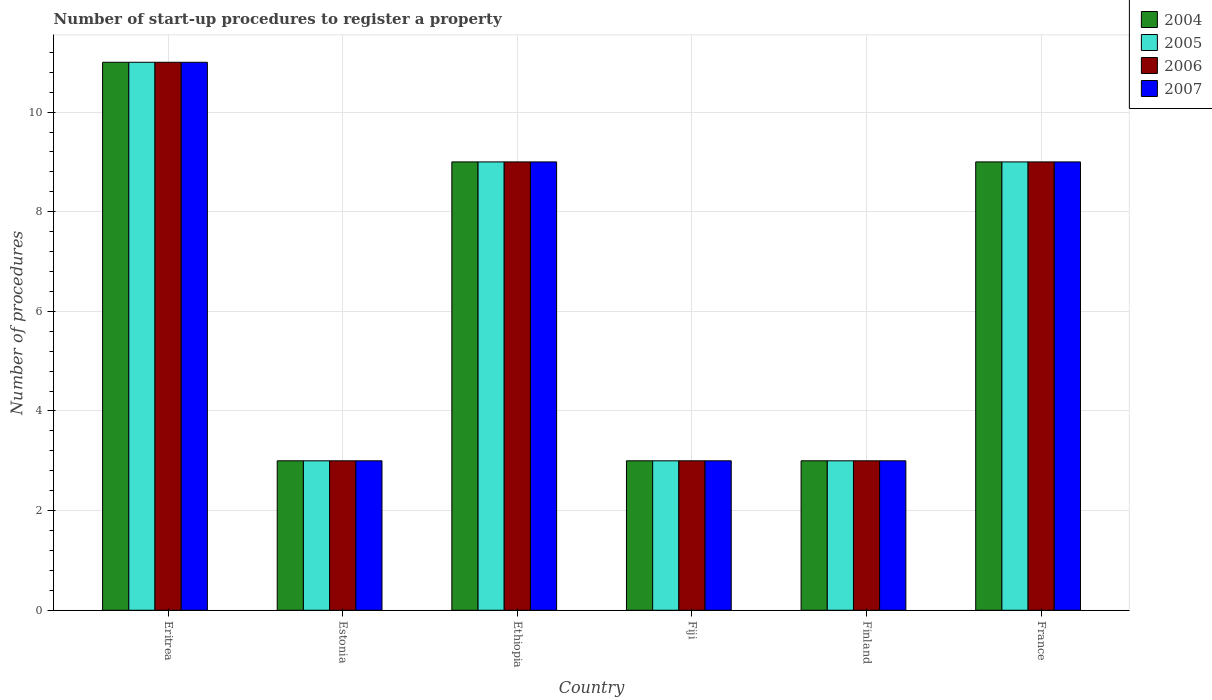How many different coloured bars are there?
Ensure brevity in your answer.  4. Are the number of bars per tick equal to the number of legend labels?
Offer a terse response. Yes. How many bars are there on the 4th tick from the right?
Offer a very short reply. 4. What is the label of the 5th group of bars from the left?
Provide a succinct answer. Finland. What is the number of procedures required to register a property in 2005 in Fiji?
Provide a succinct answer. 3. In which country was the number of procedures required to register a property in 2006 maximum?
Your response must be concise. Eritrea. In which country was the number of procedures required to register a property in 2004 minimum?
Provide a succinct answer. Estonia. What is the total number of procedures required to register a property in 2004 in the graph?
Make the answer very short. 38. What is the difference between the number of procedures required to register a property in 2006 in Eritrea and that in Estonia?
Keep it short and to the point. 8. What is the average number of procedures required to register a property in 2004 per country?
Provide a short and direct response. 6.33. What is the difference between the number of procedures required to register a property of/in 2005 and number of procedures required to register a property of/in 2006 in Estonia?
Your answer should be compact. 0. In how many countries, is the number of procedures required to register a property in 2006 greater than 4.8?
Offer a terse response. 3. What is the ratio of the number of procedures required to register a property in 2006 in Estonia to that in France?
Offer a very short reply. 0.33. Is the difference between the number of procedures required to register a property in 2005 in Eritrea and Ethiopia greater than the difference between the number of procedures required to register a property in 2006 in Eritrea and Ethiopia?
Your response must be concise. No. What is the difference between the highest and the lowest number of procedures required to register a property in 2006?
Give a very brief answer. 8. Is it the case that in every country, the sum of the number of procedures required to register a property in 2005 and number of procedures required to register a property in 2004 is greater than the number of procedures required to register a property in 2007?
Give a very brief answer. Yes. How many bars are there?
Your answer should be compact. 24. How many countries are there in the graph?
Your response must be concise. 6. What is the difference between two consecutive major ticks on the Y-axis?
Your answer should be very brief. 2. What is the title of the graph?
Keep it short and to the point. Number of start-up procedures to register a property. Does "2011" appear as one of the legend labels in the graph?
Give a very brief answer. No. What is the label or title of the X-axis?
Keep it short and to the point. Country. What is the label or title of the Y-axis?
Give a very brief answer. Number of procedures. What is the Number of procedures of 2004 in Eritrea?
Offer a very short reply. 11. What is the Number of procedures of 2005 in Eritrea?
Your answer should be compact. 11. What is the Number of procedures of 2005 in Estonia?
Offer a terse response. 3. What is the Number of procedures of 2006 in Estonia?
Ensure brevity in your answer.  3. What is the Number of procedures of 2004 in Ethiopia?
Make the answer very short. 9. What is the Number of procedures of 2005 in Ethiopia?
Provide a short and direct response. 9. What is the Number of procedures in 2007 in Ethiopia?
Give a very brief answer. 9. What is the Number of procedures in 2004 in Fiji?
Offer a terse response. 3. What is the Number of procedures in 2005 in Fiji?
Your answer should be very brief. 3. What is the Number of procedures in 2006 in Fiji?
Give a very brief answer. 3. What is the Number of procedures in 2007 in Fiji?
Your response must be concise. 3. What is the Number of procedures of 2004 in Finland?
Keep it short and to the point. 3. What is the Number of procedures of 2006 in Finland?
Ensure brevity in your answer.  3. What is the Number of procedures in 2007 in Finland?
Offer a terse response. 3. What is the Number of procedures of 2004 in France?
Make the answer very short. 9. Across all countries, what is the maximum Number of procedures of 2004?
Your answer should be very brief. 11. Across all countries, what is the maximum Number of procedures in 2005?
Offer a terse response. 11. Across all countries, what is the minimum Number of procedures of 2004?
Ensure brevity in your answer.  3. Across all countries, what is the minimum Number of procedures of 2006?
Provide a succinct answer. 3. Across all countries, what is the minimum Number of procedures of 2007?
Your answer should be compact. 3. What is the total Number of procedures in 2004 in the graph?
Offer a very short reply. 38. What is the total Number of procedures of 2005 in the graph?
Give a very brief answer. 38. What is the difference between the Number of procedures of 2004 in Eritrea and that in Estonia?
Make the answer very short. 8. What is the difference between the Number of procedures in 2005 in Eritrea and that in Estonia?
Give a very brief answer. 8. What is the difference between the Number of procedures in 2007 in Eritrea and that in Estonia?
Keep it short and to the point. 8. What is the difference between the Number of procedures of 2004 in Eritrea and that in Ethiopia?
Ensure brevity in your answer.  2. What is the difference between the Number of procedures of 2007 in Eritrea and that in Ethiopia?
Provide a succinct answer. 2. What is the difference between the Number of procedures of 2005 in Eritrea and that in Fiji?
Provide a succinct answer. 8. What is the difference between the Number of procedures in 2006 in Eritrea and that in Fiji?
Your response must be concise. 8. What is the difference between the Number of procedures of 2004 in Eritrea and that in Finland?
Make the answer very short. 8. What is the difference between the Number of procedures of 2004 in Eritrea and that in France?
Keep it short and to the point. 2. What is the difference between the Number of procedures of 2005 in Eritrea and that in France?
Give a very brief answer. 2. What is the difference between the Number of procedures in 2006 in Eritrea and that in France?
Keep it short and to the point. 2. What is the difference between the Number of procedures of 2007 in Eritrea and that in France?
Your answer should be very brief. 2. What is the difference between the Number of procedures of 2004 in Estonia and that in Ethiopia?
Give a very brief answer. -6. What is the difference between the Number of procedures of 2006 in Estonia and that in Ethiopia?
Give a very brief answer. -6. What is the difference between the Number of procedures of 2005 in Estonia and that in Fiji?
Provide a short and direct response. 0. What is the difference between the Number of procedures of 2007 in Estonia and that in Fiji?
Your answer should be compact. 0. What is the difference between the Number of procedures of 2005 in Estonia and that in Finland?
Provide a short and direct response. 0. What is the difference between the Number of procedures in 2006 in Estonia and that in Finland?
Keep it short and to the point. 0. What is the difference between the Number of procedures of 2007 in Estonia and that in Finland?
Ensure brevity in your answer.  0. What is the difference between the Number of procedures of 2005 in Estonia and that in France?
Offer a terse response. -6. What is the difference between the Number of procedures in 2006 in Estonia and that in France?
Offer a terse response. -6. What is the difference between the Number of procedures of 2007 in Estonia and that in France?
Offer a terse response. -6. What is the difference between the Number of procedures in 2004 in Ethiopia and that in Fiji?
Your answer should be compact. 6. What is the difference between the Number of procedures in 2006 in Ethiopia and that in Fiji?
Your response must be concise. 6. What is the difference between the Number of procedures of 2006 in Ethiopia and that in Finland?
Offer a very short reply. 6. What is the difference between the Number of procedures of 2006 in Ethiopia and that in France?
Ensure brevity in your answer.  0. What is the difference between the Number of procedures of 2007 in Ethiopia and that in France?
Your answer should be compact. 0. What is the difference between the Number of procedures in 2006 in Fiji and that in Finland?
Provide a short and direct response. 0. What is the difference between the Number of procedures of 2004 in Finland and that in France?
Make the answer very short. -6. What is the difference between the Number of procedures of 2004 in Eritrea and the Number of procedures of 2005 in Estonia?
Your answer should be compact. 8. What is the difference between the Number of procedures in 2004 in Eritrea and the Number of procedures in 2006 in Estonia?
Your answer should be very brief. 8. What is the difference between the Number of procedures in 2004 in Eritrea and the Number of procedures in 2007 in Estonia?
Your answer should be compact. 8. What is the difference between the Number of procedures of 2005 in Eritrea and the Number of procedures of 2006 in Estonia?
Offer a terse response. 8. What is the difference between the Number of procedures in 2005 in Eritrea and the Number of procedures in 2007 in Estonia?
Your answer should be very brief. 8. What is the difference between the Number of procedures in 2006 in Eritrea and the Number of procedures in 2007 in Estonia?
Your answer should be very brief. 8. What is the difference between the Number of procedures in 2004 in Eritrea and the Number of procedures in 2006 in Ethiopia?
Your answer should be very brief. 2. What is the difference between the Number of procedures of 2005 in Eritrea and the Number of procedures of 2006 in Ethiopia?
Your response must be concise. 2. What is the difference between the Number of procedures in 2005 in Eritrea and the Number of procedures in 2007 in Ethiopia?
Keep it short and to the point. 2. What is the difference between the Number of procedures in 2006 in Eritrea and the Number of procedures in 2007 in Ethiopia?
Your answer should be compact. 2. What is the difference between the Number of procedures of 2004 in Eritrea and the Number of procedures of 2006 in Fiji?
Your response must be concise. 8. What is the difference between the Number of procedures in 2005 in Eritrea and the Number of procedures in 2007 in Fiji?
Give a very brief answer. 8. What is the difference between the Number of procedures in 2004 in Eritrea and the Number of procedures in 2007 in Finland?
Your response must be concise. 8. What is the difference between the Number of procedures of 2005 in Eritrea and the Number of procedures of 2006 in Finland?
Offer a terse response. 8. What is the difference between the Number of procedures of 2006 in Eritrea and the Number of procedures of 2007 in Finland?
Offer a terse response. 8. What is the difference between the Number of procedures in 2004 in Eritrea and the Number of procedures in 2007 in France?
Your answer should be very brief. 2. What is the difference between the Number of procedures of 2004 in Estonia and the Number of procedures of 2005 in Ethiopia?
Provide a succinct answer. -6. What is the difference between the Number of procedures of 2006 in Estonia and the Number of procedures of 2007 in Ethiopia?
Keep it short and to the point. -6. What is the difference between the Number of procedures in 2004 in Estonia and the Number of procedures in 2005 in Fiji?
Your response must be concise. 0. What is the difference between the Number of procedures in 2004 in Estonia and the Number of procedures in 2006 in Fiji?
Keep it short and to the point. 0. What is the difference between the Number of procedures of 2004 in Estonia and the Number of procedures of 2006 in Finland?
Make the answer very short. 0. What is the difference between the Number of procedures in 2004 in Estonia and the Number of procedures in 2007 in Finland?
Keep it short and to the point. 0. What is the difference between the Number of procedures of 2004 in Estonia and the Number of procedures of 2005 in France?
Offer a terse response. -6. What is the difference between the Number of procedures in 2004 in Ethiopia and the Number of procedures in 2006 in Fiji?
Ensure brevity in your answer.  6. What is the difference between the Number of procedures in 2006 in Ethiopia and the Number of procedures in 2007 in Fiji?
Your answer should be very brief. 6. What is the difference between the Number of procedures of 2004 in Ethiopia and the Number of procedures of 2007 in Finland?
Your response must be concise. 6. What is the difference between the Number of procedures in 2005 in Ethiopia and the Number of procedures in 2006 in Finland?
Keep it short and to the point. 6. What is the difference between the Number of procedures in 2005 in Ethiopia and the Number of procedures in 2007 in Finland?
Keep it short and to the point. 6. What is the difference between the Number of procedures of 2004 in Ethiopia and the Number of procedures of 2005 in France?
Ensure brevity in your answer.  0. What is the difference between the Number of procedures in 2005 in Ethiopia and the Number of procedures in 2006 in France?
Your answer should be compact. 0. What is the difference between the Number of procedures in 2006 in Ethiopia and the Number of procedures in 2007 in France?
Provide a short and direct response. 0. What is the difference between the Number of procedures of 2004 in Fiji and the Number of procedures of 2006 in Finland?
Provide a succinct answer. 0. What is the difference between the Number of procedures in 2004 in Fiji and the Number of procedures in 2007 in Finland?
Ensure brevity in your answer.  0. What is the difference between the Number of procedures of 2005 in Fiji and the Number of procedures of 2006 in Finland?
Your response must be concise. 0. What is the difference between the Number of procedures in 2004 in Fiji and the Number of procedures in 2007 in France?
Your answer should be very brief. -6. What is the difference between the Number of procedures in 2005 in Fiji and the Number of procedures in 2006 in France?
Your answer should be compact. -6. What is the difference between the Number of procedures in 2005 in Fiji and the Number of procedures in 2007 in France?
Your answer should be compact. -6. What is the difference between the Number of procedures of 2004 in Finland and the Number of procedures of 2005 in France?
Your answer should be very brief. -6. What is the difference between the Number of procedures in 2004 in Finland and the Number of procedures in 2006 in France?
Your answer should be compact. -6. What is the difference between the Number of procedures of 2005 in Finland and the Number of procedures of 2007 in France?
Offer a terse response. -6. What is the difference between the Number of procedures in 2006 in Finland and the Number of procedures in 2007 in France?
Your answer should be compact. -6. What is the average Number of procedures in 2004 per country?
Make the answer very short. 6.33. What is the average Number of procedures in 2005 per country?
Offer a very short reply. 6.33. What is the average Number of procedures of 2006 per country?
Your answer should be very brief. 6.33. What is the average Number of procedures of 2007 per country?
Offer a very short reply. 6.33. What is the difference between the Number of procedures of 2004 and Number of procedures of 2006 in Eritrea?
Provide a short and direct response. 0. What is the difference between the Number of procedures of 2004 and Number of procedures of 2007 in Eritrea?
Ensure brevity in your answer.  0. What is the difference between the Number of procedures of 2005 and Number of procedures of 2007 in Eritrea?
Keep it short and to the point. 0. What is the difference between the Number of procedures in 2006 and Number of procedures in 2007 in Eritrea?
Provide a succinct answer. 0. What is the difference between the Number of procedures in 2004 and Number of procedures in 2006 in Estonia?
Provide a short and direct response. 0. What is the difference between the Number of procedures of 2005 and Number of procedures of 2006 in Estonia?
Give a very brief answer. 0. What is the difference between the Number of procedures in 2004 and Number of procedures in 2006 in Ethiopia?
Your answer should be compact. 0. What is the difference between the Number of procedures in 2004 and Number of procedures in 2007 in Ethiopia?
Your response must be concise. 0. What is the difference between the Number of procedures in 2004 and Number of procedures in 2007 in Fiji?
Ensure brevity in your answer.  0. What is the difference between the Number of procedures in 2004 and Number of procedures in 2006 in Finland?
Your response must be concise. 0. What is the difference between the Number of procedures in 2005 and Number of procedures in 2007 in Finland?
Your response must be concise. 0. What is the difference between the Number of procedures of 2005 and Number of procedures of 2006 in France?
Offer a terse response. 0. What is the ratio of the Number of procedures of 2004 in Eritrea to that in Estonia?
Your answer should be compact. 3.67. What is the ratio of the Number of procedures in 2005 in Eritrea to that in Estonia?
Your answer should be very brief. 3.67. What is the ratio of the Number of procedures in 2006 in Eritrea to that in Estonia?
Provide a succinct answer. 3.67. What is the ratio of the Number of procedures of 2007 in Eritrea to that in Estonia?
Your answer should be compact. 3.67. What is the ratio of the Number of procedures of 2004 in Eritrea to that in Ethiopia?
Your answer should be very brief. 1.22. What is the ratio of the Number of procedures in 2005 in Eritrea to that in Ethiopia?
Provide a succinct answer. 1.22. What is the ratio of the Number of procedures of 2006 in Eritrea to that in Ethiopia?
Provide a succinct answer. 1.22. What is the ratio of the Number of procedures in 2007 in Eritrea to that in Ethiopia?
Offer a terse response. 1.22. What is the ratio of the Number of procedures of 2004 in Eritrea to that in Fiji?
Ensure brevity in your answer.  3.67. What is the ratio of the Number of procedures of 2005 in Eritrea to that in Fiji?
Keep it short and to the point. 3.67. What is the ratio of the Number of procedures in 2006 in Eritrea to that in Fiji?
Provide a succinct answer. 3.67. What is the ratio of the Number of procedures of 2007 in Eritrea to that in Fiji?
Keep it short and to the point. 3.67. What is the ratio of the Number of procedures in 2004 in Eritrea to that in Finland?
Provide a succinct answer. 3.67. What is the ratio of the Number of procedures in 2005 in Eritrea to that in Finland?
Keep it short and to the point. 3.67. What is the ratio of the Number of procedures of 2006 in Eritrea to that in Finland?
Offer a terse response. 3.67. What is the ratio of the Number of procedures of 2007 in Eritrea to that in Finland?
Provide a succinct answer. 3.67. What is the ratio of the Number of procedures in 2004 in Eritrea to that in France?
Your answer should be compact. 1.22. What is the ratio of the Number of procedures in 2005 in Eritrea to that in France?
Make the answer very short. 1.22. What is the ratio of the Number of procedures in 2006 in Eritrea to that in France?
Offer a terse response. 1.22. What is the ratio of the Number of procedures in 2007 in Eritrea to that in France?
Provide a short and direct response. 1.22. What is the ratio of the Number of procedures of 2004 in Estonia to that in Ethiopia?
Your response must be concise. 0.33. What is the ratio of the Number of procedures of 2006 in Estonia to that in Ethiopia?
Ensure brevity in your answer.  0.33. What is the ratio of the Number of procedures of 2007 in Estonia to that in Ethiopia?
Give a very brief answer. 0.33. What is the ratio of the Number of procedures in 2004 in Estonia to that in Fiji?
Offer a very short reply. 1. What is the ratio of the Number of procedures in 2004 in Estonia to that in Finland?
Your answer should be very brief. 1. What is the ratio of the Number of procedures of 2006 in Estonia to that in Finland?
Your answer should be very brief. 1. What is the ratio of the Number of procedures of 2007 in Estonia to that in Finland?
Give a very brief answer. 1. What is the ratio of the Number of procedures in 2005 in Estonia to that in France?
Ensure brevity in your answer.  0.33. What is the ratio of the Number of procedures in 2006 in Estonia to that in France?
Your answer should be very brief. 0.33. What is the ratio of the Number of procedures in 2005 in Ethiopia to that in Fiji?
Your response must be concise. 3. What is the ratio of the Number of procedures of 2006 in Ethiopia to that in Fiji?
Keep it short and to the point. 3. What is the ratio of the Number of procedures of 2007 in Ethiopia to that in Fiji?
Your response must be concise. 3. What is the ratio of the Number of procedures of 2004 in Ethiopia to that in Finland?
Your response must be concise. 3. What is the ratio of the Number of procedures in 2007 in Ethiopia to that in Finland?
Offer a very short reply. 3. What is the ratio of the Number of procedures of 2004 in Ethiopia to that in France?
Offer a very short reply. 1. What is the ratio of the Number of procedures in 2006 in Ethiopia to that in France?
Your response must be concise. 1. What is the ratio of the Number of procedures in 2007 in Ethiopia to that in France?
Provide a short and direct response. 1. What is the ratio of the Number of procedures of 2007 in Fiji to that in Finland?
Offer a terse response. 1. What is the ratio of the Number of procedures in 2004 in Fiji to that in France?
Your answer should be compact. 0.33. What is the ratio of the Number of procedures of 2006 in Fiji to that in France?
Provide a short and direct response. 0.33. What is the ratio of the Number of procedures of 2007 in Fiji to that in France?
Offer a very short reply. 0.33. What is the ratio of the Number of procedures in 2006 in Finland to that in France?
Offer a terse response. 0.33. What is the ratio of the Number of procedures in 2007 in Finland to that in France?
Your answer should be very brief. 0.33. What is the difference between the highest and the second highest Number of procedures of 2004?
Your answer should be compact. 2. What is the difference between the highest and the second highest Number of procedures in 2006?
Offer a terse response. 2. What is the difference between the highest and the second highest Number of procedures of 2007?
Offer a terse response. 2. What is the difference between the highest and the lowest Number of procedures in 2004?
Offer a terse response. 8. What is the difference between the highest and the lowest Number of procedures of 2005?
Give a very brief answer. 8. What is the difference between the highest and the lowest Number of procedures of 2006?
Ensure brevity in your answer.  8. 